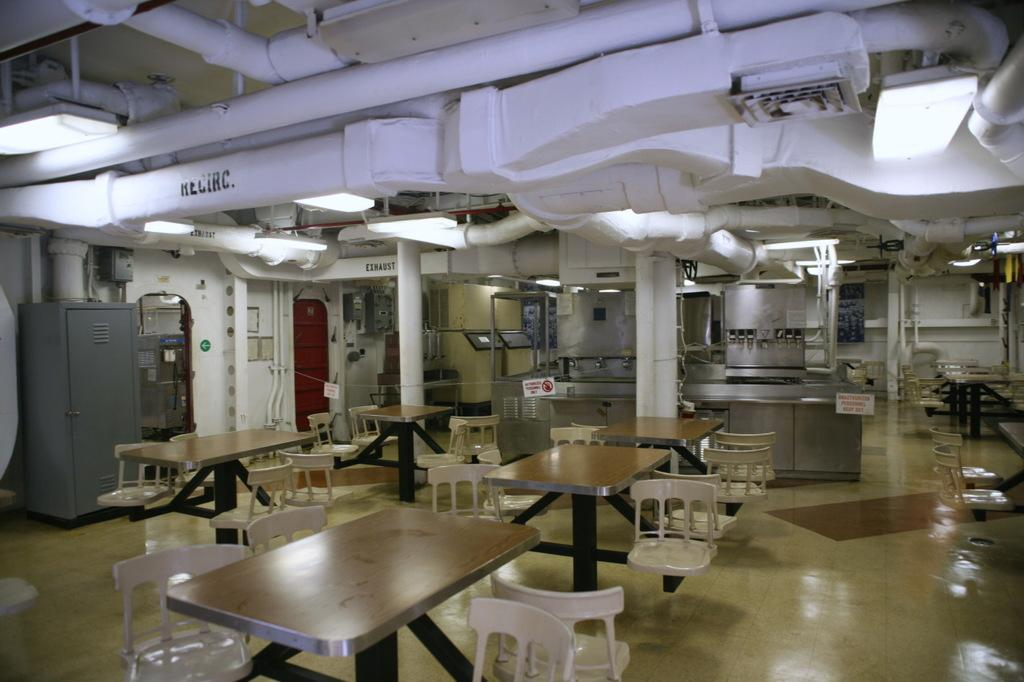What type of furniture is visible in the image? There are empty chairs and tables in the image. What else can be seen in the image besides furniture? There are different types of machines, pipes, and electronic equipment visible in the image. What type of pest can be seen crawling on the machines in the image? There are no pests visible in the image; it only shows empty chairs, tables, machines, pipes, and electronic equipment. 